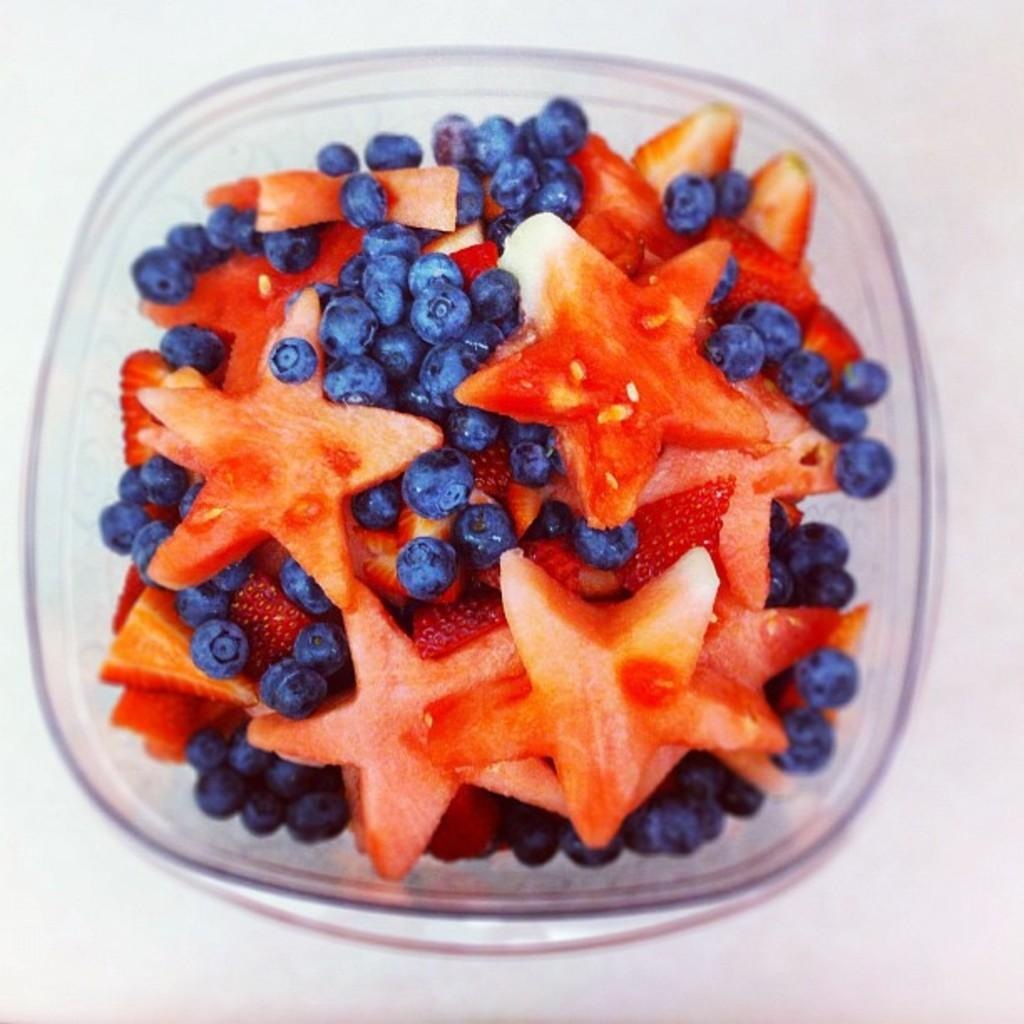What is in the bowl that is visible in the image? The bowl contains fruits. Where might the bowl be located in the image? The bowl may be placed on a table. What type of setting might the image have been taken in? The image may have been taken in a room. What type of dock can be seen in the image? There is no dock present in the image; it features a bowl of fruits. How many lamps are visible in the image? There are no lamps visible in the image. 